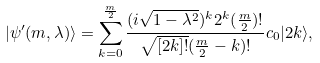<formula> <loc_0><loc_0><loc_500><loc_500>| \psi ^ { \prime } ( m , \lambda ) \rangle = \sum _ { k = 0 } ^ { \frac { m } { 2 } } \frac { ( i \sqrt { 1 - \lambda ^ { 2 } } ) ^ { k } 2 ^ { k } ( \frac { m } { 2 } ) ! } { \sqrt { [ 2 k ] ! } ( \frac { m } { 2 } - k ) ! } c _ { 0 } | 2 k \rangle ,</formula> 